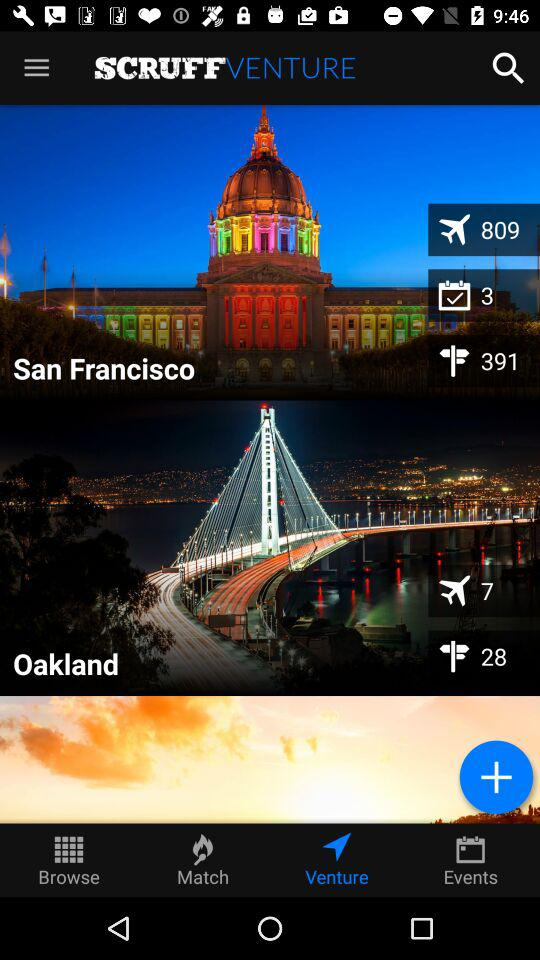What is the location? The locations are San Francisco and Oakland. 